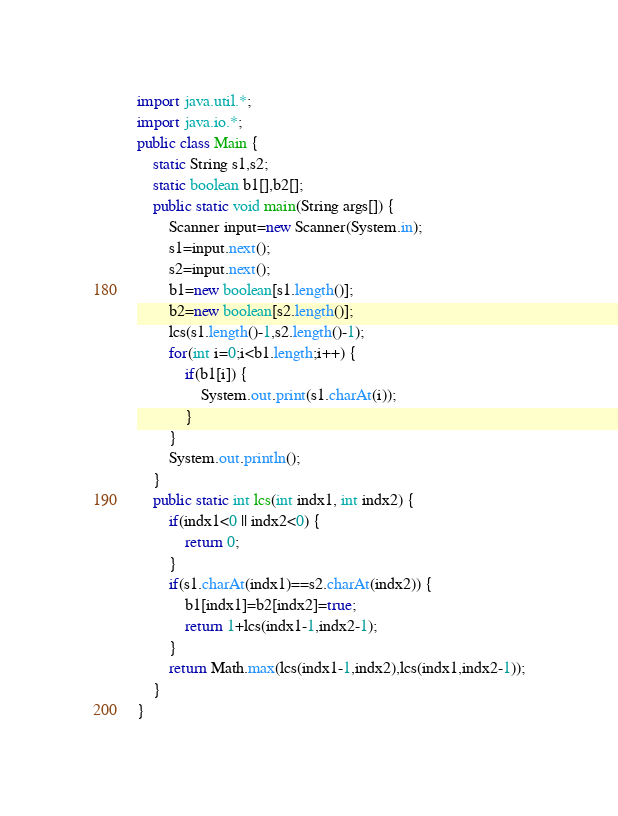<code> <loc_0><loc_0><loc_500><loc_500><_Java_>import java.util.*;
import java.io.*;
public class Main {
    static String s1,s2;
    static boolean b1[],b2[];
    public static void main(String args[]) {
        Scanner input=new Scanner(System.in);
        s1=input.next();
        s2=input.next();
        b1=new boolean[s1.length()];
        b2=new boolean[s2.length()];
        lcs(s1.length()-1,s2.length()-1);
        for(int i=0;i<b1.length;i++) {
            if(b1[i]) {
                System.out.print(s1.charAt(i));
            }
        }
        System.out.println();
    }
    public static int lcs(int indx1, int indx2) {
        if(indx1<0 || indx2<0) {
            return 0;
        }
        if(s1.charAt(indx1)==s2.charAt(indx2)) {
            b1[indx1]=b2[indx2]=true;
            return 1+lcs(indx1-1,indx2-1);
        }
        return Math.max(lcs(indx1-1,indx2),lcs(indx1,indx2-1));
    }
}
</code> 